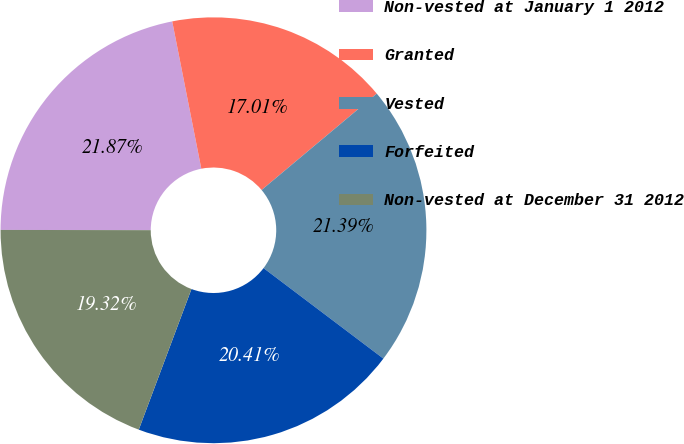Convert chart to OTSL. <chart><loc_0><loc_0><loc_500><loc_500><pie_chart><fcel>Non-vested at January 1 2012<fcel>Granted<fcel>Vested<fcel>Forfeited<fcel>Non-vested at December 31 2012<nl><fcel>21.87%<fcel>17.01%<fcel>21.39%<fcel>20.41%<fcel>19.32%<nl></chart> 